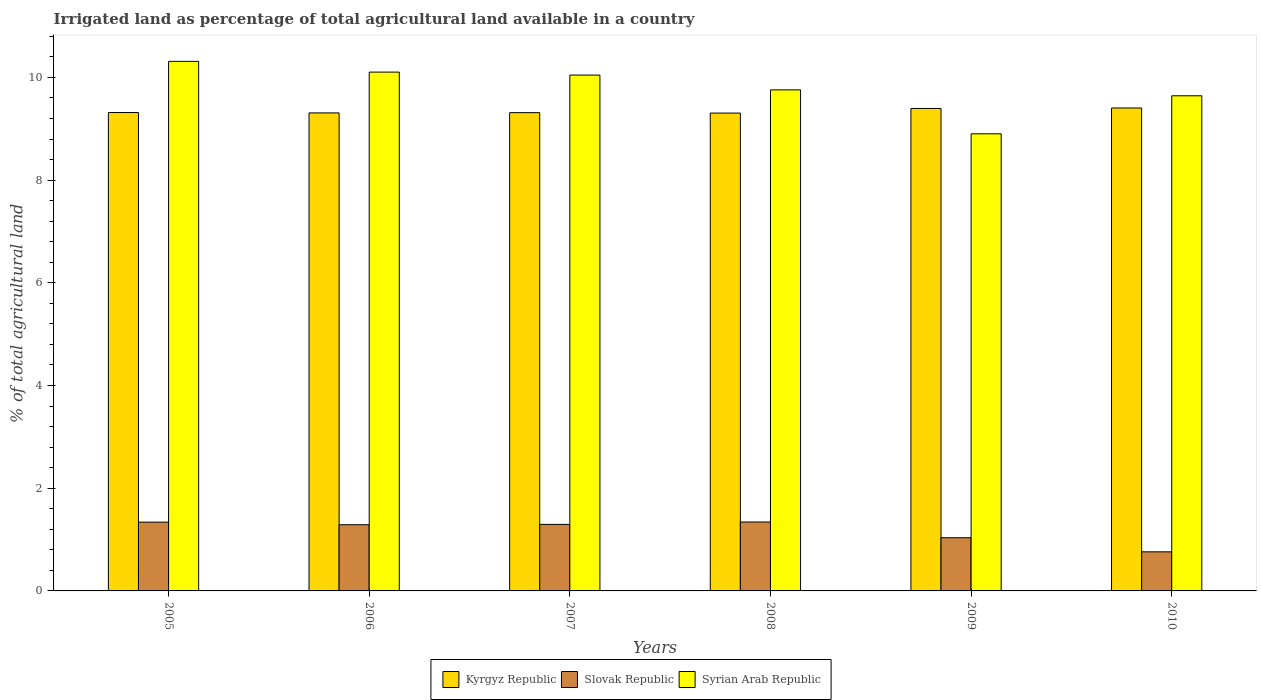How many groups of bars are there?
Offer a very short reply. 6. How many bars are there on the 6th tick from the left?
Offer a very short reply. 3. How many bars are there on the 4th tick from the right?
Offer a very short reply. 3. What is the label of the 6th group of bars from the left?
Give a very brief answer. 2010. In how many cases, is the number of bars for a given year not equal to the number of legend labels?
Your answer should be very brief. 0. What is the percentage of irrigated land in Kyrgyz Republic in 2005?
Offer a very short reply. 9.32. Across all years, what is the maximum percentage of irrigated land in Kyrgyz Republic?
Ensure brevity in your answer.  9.4. Across all years, what is the minimum percentage of irrigated land in Kyrgyz Republic?
Your response must be concise. 9.31. What is the total percentage of irrigated land in Kyrgyz Republic in the graph?
Make the answer very short. 56.04. What is the difference between the percentage of irrigated land in Kyrgyz Republic in 2006 and that in 2007?
Provide a succinct answer. -0. What is the difference between the percentage of irrigated land in Kyrgyz Republic in 2010 and the percentage of irrigated land in Slovak Republic in 2009?
Keep it short and to the point. 8.37. What is the average percentage of irrigated land in Kyrgyz Republic per year?
Give a very brief answer. 9.34. In the year 2007, what is the difference between the percentage of irrigated land in Syrian Arab Republic and percentage of irrigated land in Slovak Republic?
Your answer should be compact. 8.75. What is the ratio of the percentage of irrigated land in Slovak Republic in 2009 to that in 2010?
Your answer should be compact. 1.36. Is the difference between the percentage of irrigated land in Syrian Arab Republic in 2009 and 2010 greater than the difference between the percentage of irrigated land in Slovak Republic in 2009 and 2010?
Give a very brief answer. No. What is the difference between the highest and the second highest percentage of irrigated land in Kyrgyz Republic?
Offer a very short reply. 0.01. What is the difference between the highest and the lowest percentage of irrigated land in Syrian Arab Republic?
Ensure brevity in your answer.  1.41. In how many years, is the percentage of irrigated land in Syrian Arab Republic greater than the average percentage of irrigated land in Syrian Arab Republic taken over all years?
Your answer should be very brief. 3. What does the 1st bar from the left in 2007 represents?
Give a very brief answer. Kyrgyz Republic. What does the 2nd bar from the right in 2005 represents?
Make the answer very short. Slovak Republic. How many bars are there?
Offer a terse response. 18. Are all the bars in the graph horizontal?
Ensure brevity in your answer.  No. How many years are there in the graph?
Your answer should be compact. 6. What is the difference between two consecutive major ticks on the Y-axis?
Provide a succinct answer. 2. Are the values on the major ticks of Y-axis written in scientific E-notation?
Keep it short and to the point. No. Does the graph contain grids?
Give a very brief answer. No. Where does the legend appear in the graph?
Offer a very short reply. Bottom center. What is the title of the graph?
Make the answer very short. Irrigated land as percentage of total agricultural land available in a country. What is the label or title of the X-axis?
Give a very brief answer. Years. What is the label or title of the Y-axis?
Offer a very short reply. % of total agricultural land. What is the % of total agricultural land in Kyrgyz Republic in 2005?
Keep it short and to the point. 9.32. What is the % of total agricultural land in Slovak Republic in 2005?
Provide a short and direct response. 1.34. What is the % of total agricultural land in Syrian Arab Republic in 2005?
Give a very brief answer. 10.31. What is the % of total agricultural land in Kyrgyz Republic in 2006?
Ensure brevity in your answer.  9.31. What is the % of total agricultural land in Slovak Republic in 2006?
Your response must be concise. 1.29. What is the % of total agricultural land of Syrian Arab Republic in 2006?
Give a very brief answer. 10.1. What is the % of total agricultural land of Kyrgyz Republic in 2007?
Provide a succinct answer. 9.31. What is the % of total agricultural land in Slovak Republic in 2007?
Provide a short and direct response. 1.3. What is the % of total agricultural land of Syrian Arab Republic in 2007?
Your response must be concise. 10.05. What is the % of total agricultural land in Kyrgyz Republic in 2008?
Ensure brevity in your answer.  9.31. What is the % of total agricultural land of Slovak Republic in 2008?
Your response must be concise. 1.34. What is the % of total agricultural land of Syrian Arab Republic in 2008?
Make the answer very short. 9.76. What is the % of total agricultural land of Kyrgyz Republic in 2009?
Give a very brief answer. 9.4. What is the % of total agricultural land in Slovak Republic in 2009?
Give a very brief answer. 1.04. What is the % of total agricultural land in Syrian Arab Republic in 2009?
Make the answer very short. 8.9. What is the % of total agricultural land in Kyrgyz Republic in 2010?
Provide a succinct answer. 9.4. What is the % of total agricultural land of Slovak Republic in 2010?
Your response must be concise. 0.76. What is the % of total agricultural land of Syrian Arab Republic in 2010?
Make the answer very short. 9.64. Across all years, what is the maximum % of total agricultural land in Kyrgyz Republic?
Offer a very short reply. 9.4. Across all years, what is the maximum % of total agricultural land of Slovak Republic?
Make the answer very short. 1.34. Across all years, what is the maximum % of total agricultural land in Syrian Arab Republic?
Your response must be concise. 10.31. Across all years, what is the minimum % of total agricultural land of Kyrgyz Republic?
Provide a succinct answer. 9.31. Across all years, what is the minimum % of total agricultural land of Slovak Republic?
Ensure brevity in your answer.  0.76. Across all years, what is the minimum % of total agricultural land of Syrian Arab Republic?
Ensure brevity in your answer.  8.9. What is the total % of total agricultural land in Kyrgyz Republic in the graph?
Ensure brevity in your answer.  56.04. What is the total % of total agricultural land in Slovak Republic in the graph?
Your response must be concise. 7.06. What is the total % of total agricultural land of Syrian Arab Republic in the graph?
Provide a short and direct response. 58.76. What is the difference between the % of total agricultural land of Kyrgyz Republic in 2005 and that in 2006?
Your answer should be compact. 0.01. What is the difference between the % of total agricultural land of Slovak Republic in 2005 and that in 2006?
Give a very brief answer. 0.05. What is the difference between the % of total agricultural land of Syrian Arab Republic in 2005 and that in 2006?
Make the answer very short. 0.21. What is the difference between the % of total agricultural land in Kyrgyz Republic in 2005 and that in 2007?
Ensure brevity in your answer.  0. What is the difference between the % of total agricultural land of Slovak Republic in 2005 and that in 2007?
Provide a succinct answer. 0.04. What is the difference between the % of total agricultural land of Syrian Arab Republic in 2005 and that in 2007?
Your answer should be compact. 0.27. What is the difference between the % of total agricultural land in Kyrgyz Republic in 2005 and that in 2008?
Give a very brief answer. 0.01. What is the difference between the % of total agricultural land of Slovak Republic in 2005 and that in 2008?
Provide a succinct answer. -0. What is the difference between the % of total agricultural land of Syrian Arab Republic in 2005 and that in 2008?
Your response must be concise. 0.56. What is the difference between the % of total agricultural land in Kyrgyz Republic in 2005 and that in 2009?
Ensure brevity in your answer.  -0.08. What is the difference between the % of total agricultural land in Slovak Republic in 2005 and that in 2009?
Your answer should be very brief. 0.3. What is the difference between the % of total agricultural land in Syrian Arab Republic in 2005 and that in 2009?
Offer a terse response. 1.41. What is the difference between the % of total agricultural land in Kyrgyz Republic in 2005 and that in 2010?
Your answer should be compact. -0.09. What is the difference between the % of total agricultural land in Slovak Republic in 2005 and that in 2010?
Ensure brevity in your answer.  0.58. What is the difference between the % of total agricultural land of Syrian Arab Republic in 2005 and that in 2010?
Make the answer very short. 0.67. What is the difference between the % of total agricultural land in Kyrgyz Republic in 2006 and that in 2007?
Give a very brief answer. -0.01. What is the difference between the % of total agricultural land in Slovak Republic in 2006 and that in 2007?
Keep it short and to the point. -0.01. What is the difference between the % of total agricultural land in Syrian Arab Republic in 2006 and that in 2007?
Provide a short and direct response. 0.06. What is the difference between the % of total agricultural land of Kyrgyz Republic in 2006 and that in 2008?
Keep it short and to the point. 0. What is the difference between the % of total agricultural land in Slovak Republic in 2006 and that in 2008?
Your response must be concise. -0.05. What is the difference between the % of total agricultural land in Syrian Arab Republic in 2006 and that in 2008?
Keep it short and to the point. 0.35. What is the difference between the % of total agricultural land of Kyrgyz Republic in 2006 and that in 2009?
Your answer should be very brief. -0.09. What is the difference between the % of total agricultural land of Slovak Republic in 2006 and that in 2009?
Give a very brief answer. 0.25. What is the difference between the % of total agricultural land of Syrian Arab Republic in 2006 and that in 2009?
Ensure brevity in your answer.  1.2. What is the difference between the % of total agricultural land in Kyrgyz Republic in 2006 and that in 2010?
Provide a succinct answer. -0.1. What is the difference between the % of total agricultural land of Slovak Republic in 2006 and that in 2010?
Your answer should be very brief. 0.53. What is the difference between the % of total agricultural land in Syrian Arab Republic in 2006 and that in 2010?
Keep it short and to the point. 0.46. What is the difference between the % of total agricultural land of Kyrgyz Republic in 2007 and that in 2008?
Make the answer very short. 0.01. What is the difference between the % of total agricultural land in Slovak Republic in 2007 and that in 2008?
Your answer should be compact. -0.05. What is the difference between the % of total agricultural land in Syrian Arab Republic in 2007 and that in 2008?
Offer a terse response. 0.29. What is the difference between the % of total agricultural land in Kyrgyz Republic in 2007 and that in 2009?
Offer a terse response. -0.08. What is the difference between the % of total agricultural land of Slovak Republic in 2007 and that in 2009?
Ensure brevity in your answer.  0.26. What is the difference between the % of total agricultural land in Syrian Arab Republic in 2007 and that in 2009?
Give a very brief answer. 1.14. What is the difference between the % of total agricultural land in Kyrgyz Republic in 2007 and that in 2010?
Your response must be concise. -0.09. What is the difference between the % of total agricultural land in Slovak Republic in 2007 and that in 2010?
Ensure brevity in your answer.  0.53. What is the difference between the % of total agricultural land in Syrian Arab Republic in 2007 and that in 2010?
Provide a succinct answer. 0.4. What is the difference between the % of total agricultural land in Kyrgyz Republic in 2008 and that in 2009?
Offer a terse response. -0.09. What is the difference between the % of total agricultural land of Slovak Republic in 2008 and that in 2009?
Your answer should be compact. 0.31. What is the difference between the % of total agricultural land of Syrian Arab Republic in 2008 and that in 2009?
Offer a terse response. 0.86. What is the difference between the % of total agricultural land of Kyrgyz Republic in 2008 and that in 2010?
Your response must be concise. -0.1. What is the difference between the % of total agricultural land of Slovak Republic in 2008 and that in 2010?
Ensure brevity in your answer.  0.58. What is the difference between the % of total agricultural land of Syrian Arab Republic in 2008 and that in 2010?
Offer a terse response. 0.11. What is the difference between the % of total agricultural land in Kyrgyz Republic in 2009 and that in 2010?
Your answer should be compact. -0.01. What is the difference between the % of total agricultural land in Slovak Republic in 2009 and that in 2010?
Provide a succinct answer. 0.28. What is the difference between the % of total agricultural land of Syrian Arab Republic in 2009 and that in 2010?
Provide a succinct answer. -0.74. What is the difference between the % of total agricultural land in Kyrgyz Republic in 2005 and the % of total agricultural land in Slovak Republic in 2006?
Provide a short and direct response. 8.03. What is the difference between the % of total agricultural land in Kyrgyz Republic in 2005 and the % of total agricultural land in Syrian Arab Republic in 2006?
Your answer should be very brief. -0.79. What is the difference between the % of total agricultural land in Slovak Republic in 2005 and the % of total agricultural land in Syrian Arab Republic in 2006?
Offer a very short reply. -8.76. What is the difference between the % of total agricultural land of Kyrgyz Republic in 2005 and the % of total agricultural land of Slovak Republic in 2007?
Your answer should be compact. 8.02. What is the difference between the % of total agricultural land of Kyrgyz Republic in 2005 and the % of total agricultural land of Syrian Arab Republic in 2007?
Make the answer very short. -0.73. What is the difference between the % of total agricultural land in Slovak Republic in 2005 and the % of total agricultural land in Syrian Arab Republic in 2007?
Give a very brief answer. -8.71. What is the difference between the % of total agricultural land of Kyrgyz Republic in 2005 and the % of total agricultural land of Slovak Republic in 2008?
Offer a terse response. 7.97. What is the difference between the % of total agricultural land of Kyrgyz Republic in 2005 and the % of total agricultural land of Syrian Arab Republic in 2008?
Ensure brevity in your answer.  -0.44. What is the difference between the % of total agricultural land in Slovak Republic in 2005 and the % of total agricultural land in Syrian Arab Republic in 2008?
Ensure brevity in your answer.  -8.42. What is the difference between the % of total agricultural land in Kyrgyz Republic in 2005 and the % of total agricultural land in Slovak Republic in 2009?
Make the answer very short. 8.28. What is the difference between the % of total agricultural land in Kyrgyz Republic in 2005 and the % of total agricultural land in Syrian Arab Republic in 2009?
Your response must be concise. 0.41. What is the difference between the % of total agricultural land of Slovak Republic in 2005 and the % of total agricultural land of Syrian Arab Republic in 2009?
Give a very brief answer. -7.56. What is the difference between the % of total agricultural land in Kyrgyz Republic in 2005 and the % of total agricultural land in Slovak Republic in 2010?
Your answer should be compact. 8.55. What is the difference between the % of total agricultural land of Kyrgyz Republic in 2005 and the % of total agricultural land of Syrian Arab Republic in 2010?
Your answer should be compact. -0.33. What is the difference between the % of total agricultural land in Slovak Republic in 2005 and the % of total agricultural land in Syrian Arab Republic in 2010?
Make the answer very short. -8.3. What is the difference between the % of total agricultural land of Kyrgyz Republic in 2006 and the % of total agricultural land of Slovak Republic in 2007?
Provide a short and direct response. 8.01. What is the difference between the % of total agricultural land of Kyrgyz Republic in 2006 and the % of total agricultural land of Syrian Arab Republic in 2007?
Your response must be concise. -0.74. What is the difference between the % of total agricultural land of Slovak Republic in 2006 and the % of total agricultural land of Syrian Arab Republic in 2007?
Your answer should be compact. -8.76. What is the difference between the % of total agricultural land in Kyrgyz Republic in 2006 and the % of total agricultural land in Slovak Republic in 2008?
Provide a short and direct response. 7.97. What is the difference between the % of total agricultural land of Kyrgyz Republic in 2006 and the % of total agricultural land of Syrian Arab Republic in 2008?
Provide a succinct answer. -0.45. What is the difference between the % of total agricultural land in Slovak Republic in 2006 and the % of total agricultural land in Syrian Arab Republic in 2008?
Keep it short and to the point. -8.47. What is the difference between the % of total agricultural land in Kyrgyz Republic in 2006 and the % of total agricultural land in Slovak Republic in 2009?
Your answer should be very brief. 8.27. What is the difference between the % of total agricultural land in Kyrgyz Republic in 2006 and the % of total agricultural land in Syrian Arab Republic in 2009?
Give a very brief answer. 0.41. What is the difference between the % of total agricultural land of Slovak Republic in 2006 and the % of total agricultural land of Syrian Arab Republic in 2009?
Make the answer very short. -7.61. What is the difference between the % of total agricultural land in Kyrgyz Republic in 2006 and the % of total agricultural land in Slovak Republic in 2010?
Make the answer very short. 8.55. What is the difference between the % of total agricultural land in Kyrgyz Republic in 2006 and the % of total agricultural land in Syrian Arab Republic in 2010?
Your response must be concise. -0.33. What is the difference between the % of total agricultural land of Slovak Republic in 2006 and the % of total agricultural land of Syrian Arab Republic in 2010?
Offer a terse response. -8.35. What is the difference between the % of total agricultural land of Kyrgyz Republic in 2007 and the % of total agricultural land of Slovak Republic in 2008?
Provide a succinct answer. 7.97. What is the difference between the % of total agricultural land of Kyrgyz Republic in 2007 and the % of total agricultural land of Syrian Arab Republic in 2008?
Provide a succinct answer. -0.44. What is the difference between the % of total agricultural land of Slovak Republic in 2007 and the % of total agricultural land of Syrian Arab Republic in 2008?
Provide a short and direct response. -8.46. What is the difference between the % of total agricultural land of Kyrgyz Republic in 2007 and the % of total agricultural land of Slovak Republic in 2009?
Offer a very short reply. 8.28. What is the difference between the % of total agricultural land in Kyrgyz Republic in 2007 and the % of total agricultural land in Syrian Arab Republic in 2009?
Provide a short and direct response. 0.41. What is the difference between the % of total agricultural land in Slovak Republic in 2007 and the % of total agricultural land in Syrian Arab Republic in 2009?
Offer a very short reply. -7.61. What is the difference between the % of total agricultural land in Kyrgyz Republic in 2007 and the % of total agricultural land in Slovak Republic in 2010?
Make the answer very short. 8.55. What is the difference between the % of total agricultural land in Kyrgyz Republic in 2007 and the % of total agricultural land in Syrian Arab Republic in 2010?
Provide a short and direct response. -0.33. What is the difference between the % of total agricultural land in Slovak Republic in 2007 and the % of total agricultural land in Syrian Arab Republic in 2010?
Make the answer very short. -8.35. What is the difference between the % of total agricultural land in Kyrgyz Republic in 2008 and the % of total agricultural land in Slovak Republic in 2009?
Your answer should be compact. 8.27. What is the difference between the % of total agricultural land in Kyrgyz Republic in 2008 and the % of total agricultural land in Syrian Arab Republic in 2009?
Keep it short and to the point. 0.4. What is the difference between the % of total agricultural land in Slovak Republic in 2008 and the % of total agricultural land in Syrian Arab Republic in 2009?
Your answer should be very brief. -7.56. What is the difference between the % of total agricultural land in Kyrgyz Republic in 2008 and the % of total agricultural land in Slovak Republic in 2010?
Give a very brief answer. 8.54. What is the difference between the % of total agricultural land in Kyrgyz Republic in 2008 and the % of total agricultural land in Syrian Arab Republic in 2010?
Offer a terse response. -0.34. What is the difference between the % of total agricultural land of Slovak Republic in 2008 and the % of total agricultural land of Syrian Arab Republic in 2010?
Offer a very short reply. -8.3. What is the difference between the % of total agricultural land in Kyrgyz Republic in 2009 and the % of total agricultural land in Slovak Republic in 2010?
Your response must be concise. 8.63. What is the difference between the % of total agricultural land of Kyrgyz Republic in 2009 and the % of total agricultural land of Syrian Arab Republic in 2010?
Offer a terse response. -0.25. What is the difference between the % of total agricultural land in Slovak Republic in 2009 and the % of total agricultural land in Syrian Arab Republic in 2010?
Keep it short and to the point. -8.61. What is the average % of total agricultural land in Kyrgyz Republic per year?
Your response must be concise. 9.34. What is the average % of total agricultural land of Slovak Republic per year?
Keep it short and to the point. 1.18. What is the average % of total agricultural land in Syrian Arab Republic per year?
Provide a short and direct response. 9.79. In the year 2005, what is the difference between the % of total agricultural land of Kyrgyz Republic and % of total agricultural land of Slovak Republic?
Provide a short and direct response. 7.98. In the year 2005, what is the difference between the % of total agricultural land in Kyrgyz Republic and % of total agricultural land in Syrian Arab Republic?
Provide a short and direct response. -1. In the year 2005, what is the difference between the % of total agricultural land in Slovak Republic and % of total agricultural land in Syrian Arab Republic?
Your answer should be very brief. -8.97. In the year 2006, what is the difference between the % of total agricultural land of Kyrgyz Republic and % of total agricultural land of Slovak Republic?
Provide a short and direct response. 8.02. In the year 2006, what is the difference between the % of total agricultural land in Kyrgyz Republic and % of total agricultural land in Syrian Arab Republic?
Give a very brief answer. -0.79. In the year 2006, what is the difference between the % of total agricultural land of Slovak Republic and % of total agricultural land of Syrian Arab Republic?
Keep it short and to the point. -8.81. In the year 2007, what is the difference between the % of total agricultural land in Kyrgyz Republic and % of total agricultural land in Slovak Republic?
Your response must be concise. 8.02. In the year 2007, what is the difference between the % of total agricultural land of Kyrgyz Republic and % of total agricultural land of Syrian Arab Republic?
Offer a very short reply. -0.73. In the year 2007, what is the difference between the % of total agricultural land in Slovak Republic and % of total agricultural land in Syrian Arab Republic?
Make the answer very short. -8.75. In the year 2008, what is the difference between the % of total agricultural land in Kyrgyz Republic and % of total agricultural land in Slovak Republic?
Your answer should be very brief. 7.96. In the year 2008, what is the difference between the % of total agricultural land in Kyrgyz Republic and % of total agricultural land in Syrian Arab Republic?
Ensure brevity in your answer.  -0.45. In the year 2008, what is the difference between the % of total agricultural land in Slovak Republic and % of total agricultural land in Syrian Arab Republic?
Your answer should be very brief. -8.41. In the year 2009, what is the difference between the % of total agricultural land of Kyrgyz Republic and % of total agricultural land of Slovak Republic?
Your response must be concise. 8.36. In the year 2009, what is the difference between the % of total agricultural land in Kyrgyz Republic and % of total agricultural land in Syrian Arab Republic?
Your answer should be compact. 0.49. In the year 2009, what is the difference between the % of total agricultural land in Slovak Republic and % of total agricultural land in Syrian Arab Republic?
Provide a short and direct response. -7.87. In the year 2010, what is the difference between the % of total agricultural land of Kyrgyz Republic and % of total agricultural land of Slovak Republic?
Offer a terse response. 8.64. In the year 2010, what is the difference between the % of total agricultural land in Kyrgyz Republic and % of total agricultural land in Syrian Arab Republic?
Give a very brief answer. -0.24. In the year 2010, what is the difference between the % of total agricultural land in Slovak Republic and % of total agricultural land in Syrian Arab Republic?
Provide a short and direct response. -8.88. What is the ratio of the % of total agricultural land of Kyrgyz Republic in 2005 to that in 2006?
Offer a terse response. 1. What is the ratio of the % of total agricultural land in Slovak Republic in 2005 to that in 2006?
Provide a succinct answer. 1.04. What is the ratio of the % of total agricultural land in Syrian Arab Republic in 2005 to that in 2006?
Provide a short and direct response. 1.02. What is the ratio of the % of total agricultural land in Kyrgyz Republic in 2005 to that in 2007?
Your answer should be very brief. 1. What is the ratio of the % of total agricultural land of Slovak Republic in 2005 to that in 2007?
Provide a short and direct response. 1.03. What is the ratio of the % of total agricultural land in Syrian Arab Republic in 2005 to that in 2007?
Your answer should be compact. 1.03. What is the ratio of the % of total agricultural land in Kyrgyz Republic in 2005 to that in 2008?
Provide a short and direct response. 1. What is the ratio of the % of total agricultural land in Slovak Republic in 2005 to that in 2008?
Keep it short and to the point. 1. What is the ratio of the % of total agricultural land of Syrian Arab Republic in 2005 to that in 2008?
Your answer should be compact. 1.06. What is the ratio of the % of total agricultural land of Slovak Republic in 2005 to that in 2009?
Your response must be concise. 1.29. What is the ratio of the % of total agricultural land in Syrian Arab Republic in 2005 to that in 2009?
Your answer should be compact. 1.16. What is the ratio of the % of total agricultural land of Kyrgyz Republic in 2005 to that in 2010?
Ensure brevity in your answer.  0.99. What is the ratio of the % of total agricultural land in Slovak Republic in 2005 to that in 2010?
Your response must be concise. 1.76. What is the ratio of the % of total agricultural land of Syrian Arab Republic in 2005 to that in 2010?
Your answer should be compact. 1.07. What is the ratio of the % of total agricultural land of Kyrgyz Republic in 2006 to that in 2007?
Your answer should be compact. 1. What is the ratio of the % of total agricultural land in Syrian Arab Republic in 2006 to that in 2007?
Keep it short and to the point. 1.01. What is the ratio of the % of total agricultural land in Slovak Republic in 2006 to that in 2008?
Offer a very short reply. 0.96. What is the ratio of the % of total agricultural land of Syrian Arab Republic in 2006 to that in 2008?
Your answer should be compact. 1.04. What is the ratio of the % of total agricultural land of Slovak Republic in 2006 to that in 2009?
Your answer should be compact. 1.24. What is the ratio of the % of total agricultural land of Syrian Arab Republic in 2006 to that in 2009?
Offer a terse response. 1.14. What is the ratio of the % of total agricultural land of Kyrgyz Republic in 2006 to that in 2010?
Your response must be concise. 0.99. What is the ratio of the % of total agricultural land in Slovak Republic in 2006 to that in 2010?
Keep it short and to the point. 1.69. What is the ratio of the % of total agricultural land of Syrian Arab Republic in 2006 to that in 2010?
Provide a succinct answer. 1.05. What is the ratio of the % of total agricultural land of Syrian Arab Republic in 2007 to that in 2008?
Your answer should be very brief. 1.03. What is the ratio of the % of total agricultural land of Syrian Arab Republic in 2007 to that in 2009?
Your response must be concise. 1.13. What is the ratio of the % of total agricultural land in Kyrgyz Republic in 2007 to that in 2010?
Give a very brief answer. 0.99. What is the ratio of the % of total agricultural land in Slovak Republic in 2007 to that in 2010?
Ensure brevity in your answer.  1.7. What is the ratio of the % of total agricultural land in Syrian Arab Republic in 2007 to that in 2010?
Your response must be concise. 1.04. What is the ratio of the % of total agricultural land of Slovak Republic in 2008 to that in 2009?
Ensure brevity in your answer.  1.3. What is the ratio of the % of total agricultural land of Syrian Arab Republic in 2008 to that in 2009?
Your answer should be very brief. 1.1. What is the ratio of the % of total agricultural land in Slovak Republic in 2008 to that in 2010?
Provide a succinct answer. 1.76. What is the ratio of the % of total agricultural land of Syrian Arab Republic in 2008 to that in 2010?
Offer a terse response. 1.01. What is the ratio of the % of total agricultural land of Kyrgyz Republic in 2009 to that in 2010?
Offer a terse response. 1. What is the ratio of the % of total agricultural land of Slovak Republic in 2009 to that in 2010?
Offer a very short reply. 1.36. What is the ratio of the % of total agricultural land of Syrian Arab Republic in 2009 to that in 2010?
Your response must be concise. 0.92. What is the difference between the highest and the second highest % of total agricultural land of Kyrgyz Republic?
Your response must be concise. 0.01. What is the difference between the highest and the second highest % of total agricultural land of Slovak Republic?
Offer a very short reply. 0. What is the difference between the highest and the second highest % of total agricultural land in Syrian Arab Republic?
Provide a short and direct response. 0.21. What is the difference between the highest and the lowest % of total agricultural land of Kyrgyz Republic?
Your answer should be compact. 0.1. What is the difference between the highest and the lowest % of total agricultural land of Slovak Republic?
Provide a succinct answer. 0.58. What is the difference between the highest and the lowest % of total agricultural land of Syrian Arab Republic?
Keep it short and to the point. 1.41. 